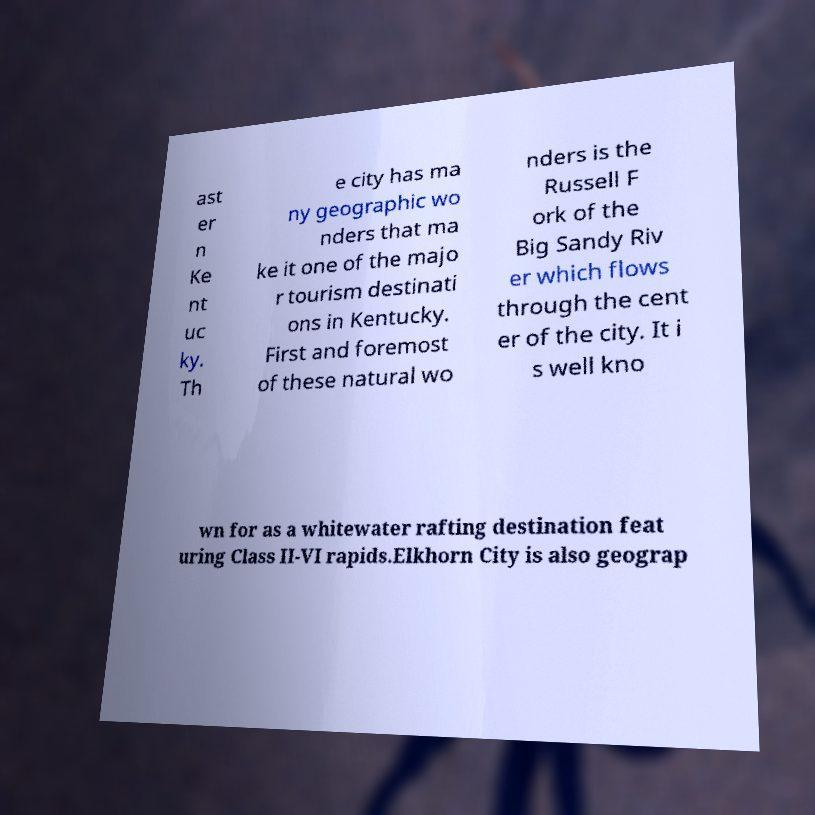Please identify and transcribe the text found in this image. ast er n Ke nt uc ky. Th e city has ma ny geographic wo nders that ma ke it one of the majo r tourism destinati ons in Kentucky. First and foremost of these natural wo nders is the Russell F ork of the Big Sandy Riv er which flows through the cent er of the city. It i s well kno wn for as a whitewater rafting destination feat uring Class II-VI rapids.Elkhorn City is also geograp 